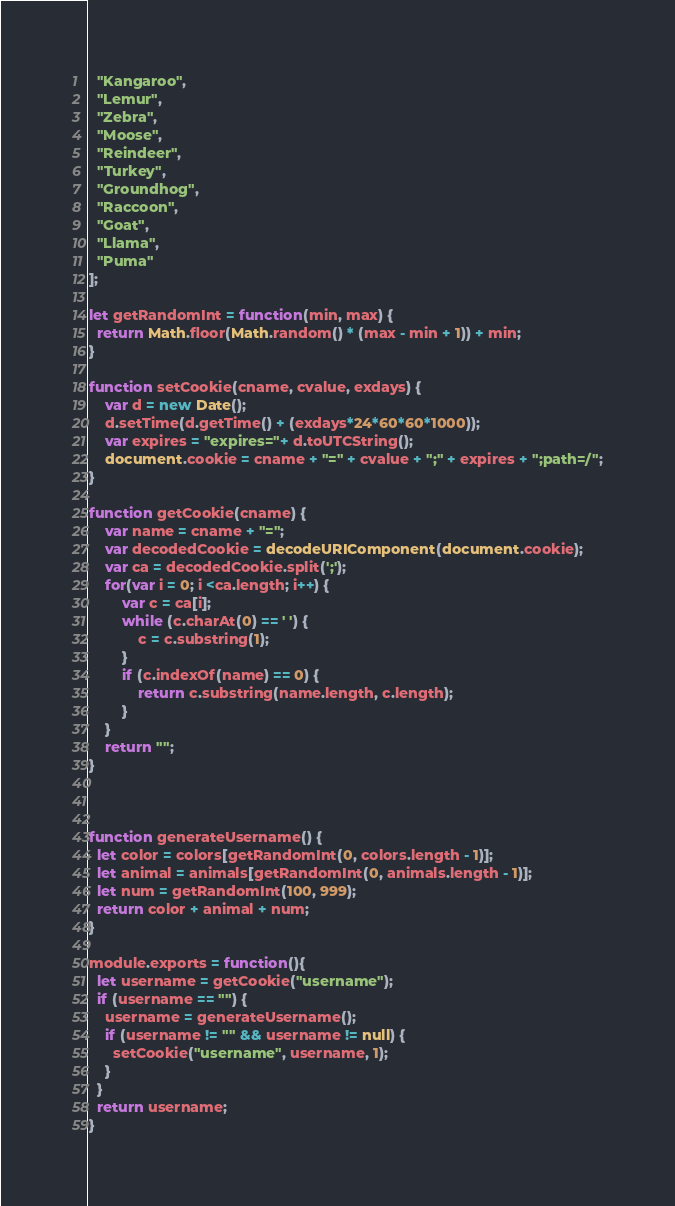<code> <loc_0><loc_0><loc_500><loc_500><_JavaScript_>  "Kangaroo",
  "Lemur",
  "Zebra",
  "Moose",
  "Reindeer",
  "Turkey",
  "Groundhog",
  "Raccoon",
  "Goat",
  "Llama",
  "Puma"
];

let getRandomInt = function(min, max) {
  return Math.floor(Math.random() * (max - min + 1)) + min;
}

function setCookie(cname, cvalue, exdays) {
    var d = new Date();
    d.setTime(d.getTime() + (exdays*24*60*60*1000));
    var expires = "expires="+ d.toUTCString();
    document.cookie = cname + "=" + cvalue + ";" + expires + ";path=/";
}

function getCookie(cname) {
    var name = cname + "=";
    var decodedCookie = decodeURIComponent(document.cookie);
    var ca = decodedCookie.split(';');
    for(var i = 0; i <ca.length; i++) {
        var c = ca[i];
        while (c.charAt(0) == ' ') {
            c = c.substring(1);
        }
        if (c.indexOf(name) == 0) {
            return c.substring(name.length, c.length);
        }
    }
    return "";
}



function generateUsername() {
  let color = colors[getRandomInt(0, colors.length - 1)];
  let animal = animals[getRandomInt(0, animals.length - 1)];
  let num = getRandomInt(100, 999);
  return color + animal + num;
}

module.exports = function(){
  let username = getCookie("username");
  if (username == "") {
    username = generateUsername();
    if (username != "" && username != null) {
      setCookie("username", username, 1);
    }
  }
  return username;
}</code> 